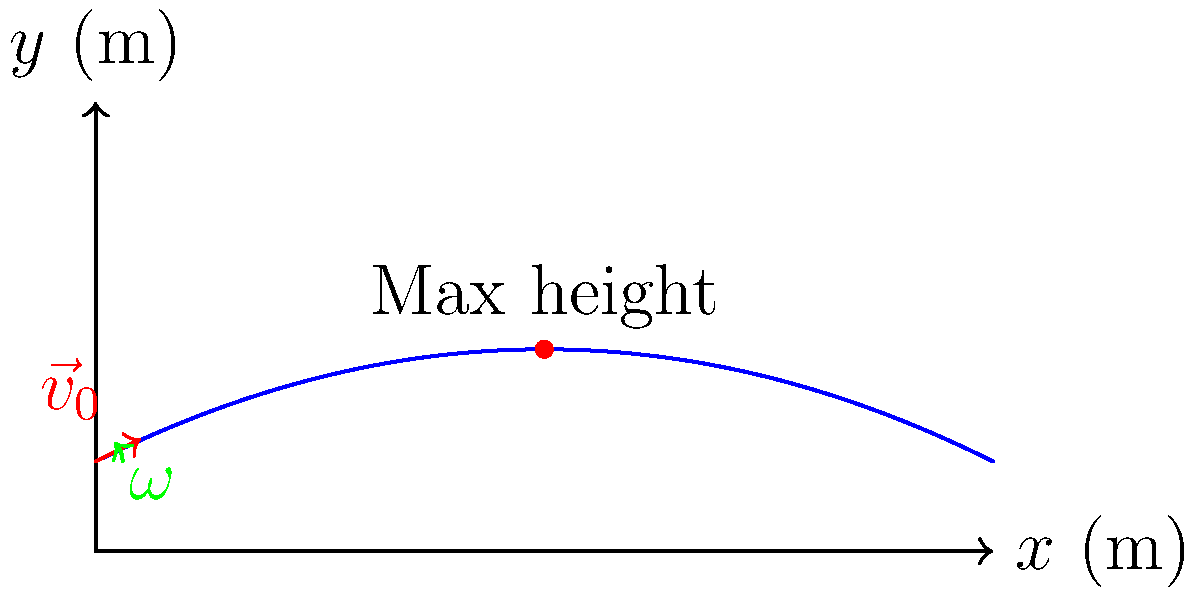Given a tennis ball hit with an initial velocity $\vec{v}_0 = (20\text{ m/s}, 10\text{ m/s})$ and a topspin of $\omega = 2000\text{ rpm}$, use a machine learning model to predict the maximum height reached by the ball. Assume the effects of air resistance and the Magnus force are significant. How would you approach this problem using machine learning techniques? To approach this problem using machine learning techniques, we can follow these steps:

1. Data Collection:
   - Gather a large dataset of tennis ball trajectories with various initial velocities and spin rates.
   - Include information on air resistance and Magnus effect for each trajectory.
   - Record the maximum height reached for each trajectory.

2. Feature Selection:
   - Use initial velocity components $(v_x, v_y)$ as features.
   - Include the spin rate $\omega$ as a feature.
   - Consider adding derived features such as total initial speed $\|\vec{v}_0\|$ and launch angle $\theta = \tan^{-1}(v_y/v_x)$.

3. Data Preprocessing:
   - Normalize features to ensure they are on the same scale.
   - Split the data into training and testing sets.

4. Model Selection:
   - Choose a regression model suitable for this task, such as:
     a) Random Forest Regression
     b) Gradient Boosting Regression (e.g., XGBoost)
     c) Neural Network Regression

5. Model Training:
   - Train the chosen model on the training data.
   - Use cross-validation to tune hyperparameters and prevent overfitting.

6. Model Evaluation:
   - Evaluate the model's performance on the test set using metrics such as Mean Squared Error (MSE) or Root Mean Squared Error (RMSE).

7. Prediction:
   - Use the trained model to predict the maximum height for the given initial conditions:
     $\vec{v}_0 = (20\text{ m/s}, 10\text{ m/s})$ and $\omega = 2000\text{ rpm}$

8. Refinement:
   - If the model's performance is not satisfactory, consider:
     a) Collecting more data
     b) Feature engineering (e.g., including air density, ball properties)
     c) Trying more complex models or ensemble methods

This approach allows the model to learn the complex relationships between initial conditions and maximum height, accounting for air resistance and the Magnus effect without explicitly modeling these physical phenomena.
Answer: Regression model trained on trajectory data, using initial velocity and spin rate as features to predict maximum height. 